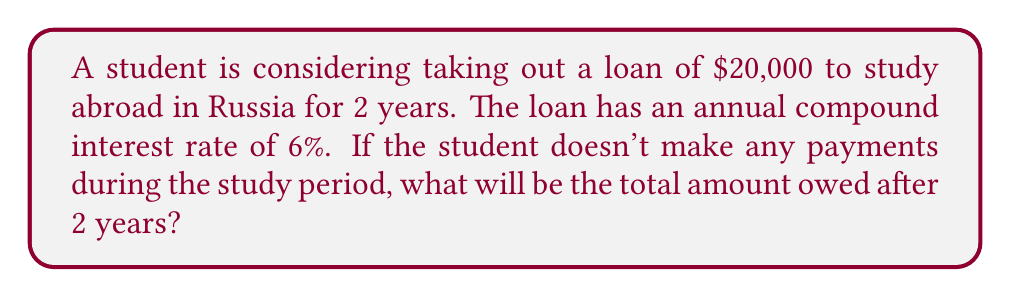Provide a solution to this math problem. To solve this problem, we'll use the compound interest formula:

$$A = P(1 + r)^t$$

Where:
$A$ = final amount
$P$ = principal (initial loan amount)
$r$ = annual interest rate (as a decimal)
$t$ = time in years

Given:
$P = \$20,000$
$r = 6\% = 0.06$
$t = 2$ years

Let's substitute these values into the formula:

$$A = 20000(1 + 0.06)^2$$

Now, let's calculate step-by-step:

1) First, calculate $(1 + 0.06)^2$:
   $$(1.06)^2 = 1.1236$$

2) Multiply this by the principal:
   $$20000 \times 1.1236 = 22472$$

Therefore, after 2 years, the student will owe $22,472.
Answer: $22,472 